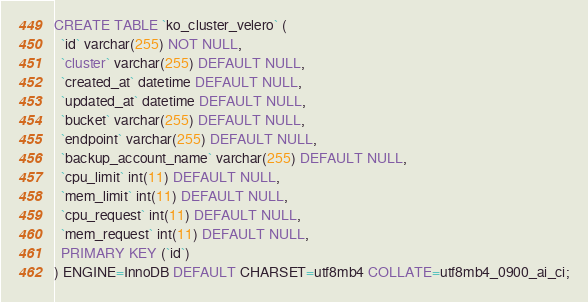Convert code to text. <code><loc_0><loc_0><loc_500><loc_500><_SQL_>
CREATE TABLE `ko_cluster_velero` (
  `id` varchar(255) NOT NULL,
  `cluster` varchar(255) DEFAULT NULL,
  `created_at` datetime DEFAULT NULL,
  `updated_at` datetime DEFAULT NULL,
  `bucket` varchar(255) DEFAULT NULL,
  `endpoint` varchar(255) DEFAULT NULL,
  `backup_account_name` varchar(255) DEFAULT NULL,
  `cpu_limit` int(11) DEFAULT NULL,
  `mem_limit` int(11) DEFAULT NULL,
  `cpu_request` int(11) DEFAULT NULL,
  `mem_request` int(11) DEFAULT NULL,
  PRIMARY KEY (`id`)
) ENGINE=InnoDB DEFAULT CHARSET=utf8mb4 COLLATE=utf8mb4_0900_ai_ci;</code> 